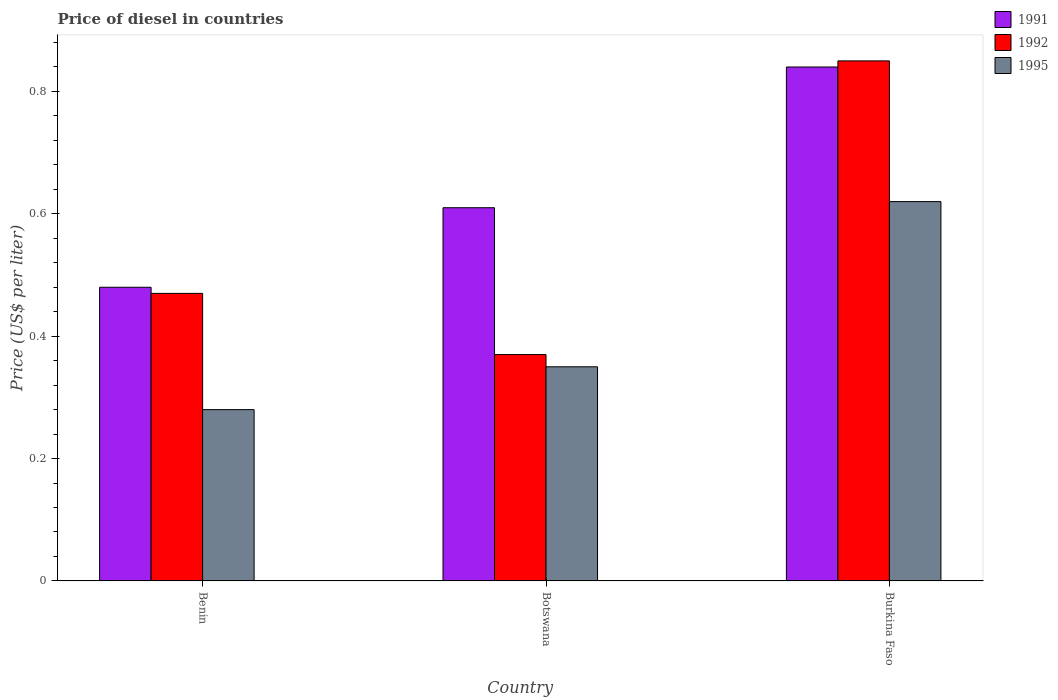How many different coloured bars are there?
Offer a terse response. 3. Are the number of bars per tick equal to the number of legend labels?
Your response must be concise. Yes. Are the number of bars on each tick of the X-axis equal?
Your response must be concise. Yes. How many bars are there on the 2nd tick from the left?
Make the answer very short. 3. What is the label of the 1st group of bars from the left?
Give a very brief answer. Benin. In how many cases, is the number of bars for a given country not equal to the number of legend labels?
Your response must be concise. 0. What is the price of diesel in 1995 in Burkina Faso?
Your response must be concise. 0.62. Across all countries, what is the maximum price of diesel in 1991?
Provide a short and direct response. 0.84. Across all countries, what is the minimum price of diesel in 1991?
Provide a short and direct response. 0.48. In which country was the price of diesel in 1992 maximum?
Provide a short and direct response. Burkina Faso. In which country was the price of diesel in 1992 minimum?
Offer a very short reply. Botswana. What is the total price of diesel in 1991 in the graph?
Your answer should be very brief. 1.93. What is the difference between the price of diesel in 1995 in Benin and that in Burkina Faso?
Your answer should be very brief. -0.34. What is the difference between the price of diesel in 1992 in Burkina Faso and the price of diesel in 1995 in Benin?
Make the answer very short. 0.57. What is the average price of diesel in 1992 per country?
Your answer should be very brief. 0.56. What is the difference between the price of diesel of/in 1992 and price of diesel of/in 1991 in Benin?
Offer a very short reply. -0.01. In how many countries, is the price of diesel in 1992 greater than 0.12 US$?
Offer a very short reply. 3. What is the ratio of the price of diesel in 1995 in Benin to that in Botswana?
Give a very brief answer. 0.8. Is the price of diesel in 1991 in Benin less than that in Burkina Faso?
Your answer should be very brief. Yes. What is the difference between the highest and the second highest price of diesel in 1991?
Your answer should be compact. 0.23. What is the difference between the highest and the lowest price of diesel in 1991?
Your response must be concise. 0.36. Is the sum of the price of diesel in 1992 in Benin and Burkina Faso greater than the maximum price of diesel in 1995 across all countries?
Your answer should be very brief. Yes. What does the 3rd bar from the left in Burkina Faso represents?
Provide a succinct answer. 1995. Is it the case that in every country, the sum of the price of diesel in 1991 and price of diesel in 1995 is greater than the price of diesel in 1992?
Make the answer very short. Yes. How many bars are there?
Provide a short and direct response. 9. Are all the bars in the graph horizontal?
Offer a very short reply. No. How many countries are there in the graph?
Offer a very short reply. 3. Are the values on the major ticks of Y-axis written in scientific E-notation?
Offer a very short reply. No. Does the graph contain grids?
Provide a succinct answer. No. Where does the legend appear in the graph?
Keep it short and to the point. Top right. How are the legend labels stacked?
Offer a terse response. Vertical. What is the title of the graph?
Offer a very short reply. Price of diesel in countries. What is the label or title of the Y-axis?
Your answer should be compact. Price (US$ per liter). What is the Price (US$ per liter) of 1991 in Benin?
Provide a short and direct response. 0.48. What is the Price (US$ per liter) in 1992 in Benin?
Give a very brief answer. 0.47. What is the Price (US$ per liter) of 1995 in Benin?
Your answer should be very brief. 0.28. What is the Price (US$ per liter) in 1991 in Botswana?
Provide a succinct answer. 0.61. What is the Price (US$ per liter) in 1992 in Botswana?
Offer a terse response. 0.37. What is the Price (US$ per liter) of 1995 in Botswana?
Keep it short and to the point. 0.35. What is the Price (US$ per liter) in 1991 in Burkina Faso?
Keep it short and to the point. 0.84. What is the Price (US$ per liter) in 1992 in Burkina Faso?
Make the answer very short. 0.85. What is the Price (US$ per liter) in 1995 in Burkina Faso?
Your answer should be compact. 0.62. Across all countries, what is the maximum Price (US$ per liter) of 1991?
Give a very brief answer. 0.84. Across all countries, what is the maximum Price (US$ per liter) in 1995?
Provide a short and direct response. 0.62. Across all countries, what is the minimum Price (US$ per liter) in 1991?
Offer a terse response. 0.48. Across all countries, what is the minimum Price (US$ per liter) of 1992?
Provide a succinct answer. 0.37. Across all countries, what is the minimum Price (US$ per liter) of 1995?
Keep it short and to the point. 0.28. What is the total Price (US$ per liter) in 1991 in the graph?
Provide a succinct answer. 1.93. What is the total Price (US$ per liter) of 1992 in the graph?
Offer a terse response. 1.69. What is the total Price (US$ per liter) of 1995 in the graph?
Offer a very short reply. 1.25. What is the difference between the Price (US$ per liter) in 1991 in Benin and that in Botswana?
Ensure brevity in your answer.  -0.13. What is the difference between the Price (US$ per liter) in 1992 in Benin and that in Botswana?
Your response must be concise. 0.1. What is the difference between the Price (US$ per liter) of 1995 in Benin and that in Botswana?
Your answer should be very brief. -0.07. What is the difference between the Price (US$ per liter) of 1991 in Benin and that in Burkina Faso?
Make the answer very short. -0.36. What is the difference between the Price (US$ per liter) of 1992 in Benin and that in Burkina Faso?
Your answer should be very brief. -0.38. What is the difference between the Price (US$ per liter) in 1995 in Benin and that in Burkina Faso?
Provide a short and direct response. -0.34. What is the difference between the Price (US$ per liter) of 1991 in Botswana and that in Burkina Faso?
Make the answer very short. -0.23. What is the difference between the Price (US$ per liter) in 1992 in Botswana and that in Burkina Faso?
Make the answer very short. -0.48. What is the difference between the Price (US$ per liter) of 1995 in Botswana and that in Burkina Faso?
Ensure brevity in your answer.  -0.27. What is the difference between the Price (US$ per liter) of 1991 in Benin and the Price (US$ per liter) of 1992 in Botswana?
Your answer should be compact. 0.11. What is the difference between the Price (US$ per liter) in 1991 in Benin and the Price (US$ per liter) in 1995 in Botswana?
Keep it short and to the point. 0.13. What is the difference between the Price (US$ per liter) in 1992 in Benin and the Price (US$ per liter) in 1995 in Botswana?
Your response must be concise. 0.12. What is the difference between the Price (US$ per liter) in 1991 in Benin and the Price (US$ per liter) in 1992 in Burkina Faso?
Your answer should be compact. -0.37. What is the difference between the Price (US$ per liter) in 1991 in Benin and the Price (US$ per liter) in 1995 in Burkina Faso?
Your answer should be compact. -0.14. What is the difference between the Price (US$ per liter) of 1992 in Benin and the Price (US$ per liter) of 1995 in Burkina Faso?
Provide a succinct answer. -0.15. What is the difference between the Price (US$ per liter) in 1991 in Botswana and the Price (US$ per liter) in 1992 in Burkina Faso?
Offer a very short reply. -0.24. What is the difference between the Price (US$ per liter) of 1991 in Botswana and the Price (US$ per liter) of 1995 in Burkina Faso?
Offer a very short reply. -0.01. What is the average Price (US$ per liter) of 1991 per country?
Your response must be concise. 0.64. What is the average Price (US$ per liter) in 1992 per country?
Offer a terse response. 0.56. What is the average Price (US$ per liter) of 1995 per country?
Offer a terse response. 0.42. What is the difference between the Price (US$ per liter) in 1992 and Price (US$ per liter) in 1995 in Benin?
Offer a very short reply. 0.19. What is the difference between the Price (US$ per liter) in 1991 and Price (US$ per liter) in 1992 in Botswana?
Ensure brevity in your answer.  0.24. What is the difference between the Price (US$ per liter) in 1991 and Price (US$ per liter) in 1995 in Botswana?
Provide a succinct answer. 0.26. What is the difference between the Price (US$ per liter) of 1992 and Price (US$ per liter) of 1995 in Botswana?
Your response must be concise. 0.02. What is the difference between the Price (US$ per liter) in 1991 and Price (US$ per liter) in 1992 in Burkina Faso?
Your answer should be very brief. -0.01. What is the difference between the Price (US$ per liter) in 1991 and Price (US$ per liter) in 1995 in Burkina Faso?
Provide a short and direct response. 0.22. What is the difference between the Price (US$ per liter) of 1992 and Price (US$ per liter) of 1995 in Burkina Faso?
Keep it short and to the point. 0.23. What is the ratio of the Price (US$ per liter) of 1991 in Benin to that in Botswana?
Keep it short and to the point. 0.79. What is the ratio of the Price (US$ per liter) of 1992 in Benin to that in Botswana?
Your answer should be very brief. 1.27. What is the ratio of the Price (US$ per liter) of 1995 in Benin to that in Botswana?
Your answer should be compact. 0.8. What is the ratio of the Price (US$ per liter) of 1992 in Benin to that in Burkina Faso?
Make the answer very short. 0.55. What is the ratio of the Price (US$ per liter) of 1995 in Benin to that in Burkina Faso?
Provide a short and direct response. 0.45. What is the ratio of the Price (US$ per liter) in 1991 in Botswana to that in Burkina Faso?
Provide a succinct answer. 0.73. What is the ratio of the Price (US$ per liter) in 1992 in Botswana to that in Burkina Faso?
Your answer should be compact. 0.44. What is the ratio of the Price (US$ per liter) in 1995 in Botswana to that in Burkina Faso?
Ensure brevity in your answer.  0.56. What is the difference between the highest and the second highest Price (US$ per liter) of 1991?
Give a very brief answer. 0.23. What is the difference between the highest and the second highest Price (US$ per liter) of 1992?
Your answer should be very brief. 0.38. What is the difference between the highest and the second highest Price (US$ per liter) of 1995?
Provide a short and direct response. 0.27. What is the difference between the highest and the lowest Price (US$ per liter) of 1991?
Offer a terse response. 0.36. What is the difference between the highest and the lowest Price (US$ per liter) in 1992?
Make the answer very short. 0.48. What is the difference between the highest and the lowest Price (US$ per liter) in 1995?
Make the answer very short. 0.34. 